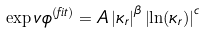Convert formula to latex. <formula><loc_0><loc_0><loc_500><loc_500>\exp v { \phi } ^ { \mathrm ( f i t ) } = A \left | \kappa _ { r } \right | ^ { \beta } \left | \ln ( \kappa _ { r } ) \right | ^ { c }</formula> 